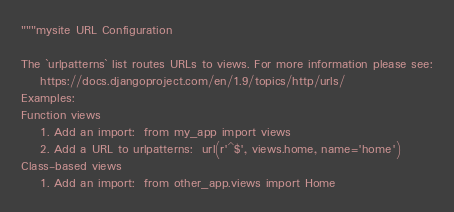Convert code to text. <code><loc_0><loc_0><loc_500><loc_500><_Python_>"""mysite URL Configuration

The `urlpatterns` list routes URLs to views. For more information please see:
    https://docs.djangoproject.com/en/1.9/topics/http/urls/
Examples:
Function views
    1. Add an import:  from my_app import views
    2. Add a URL to urlpatterns:  url(r'^$', views.home, name='home')
Class-based views
    1. Add an import:  from other_app.views import Home</code> 